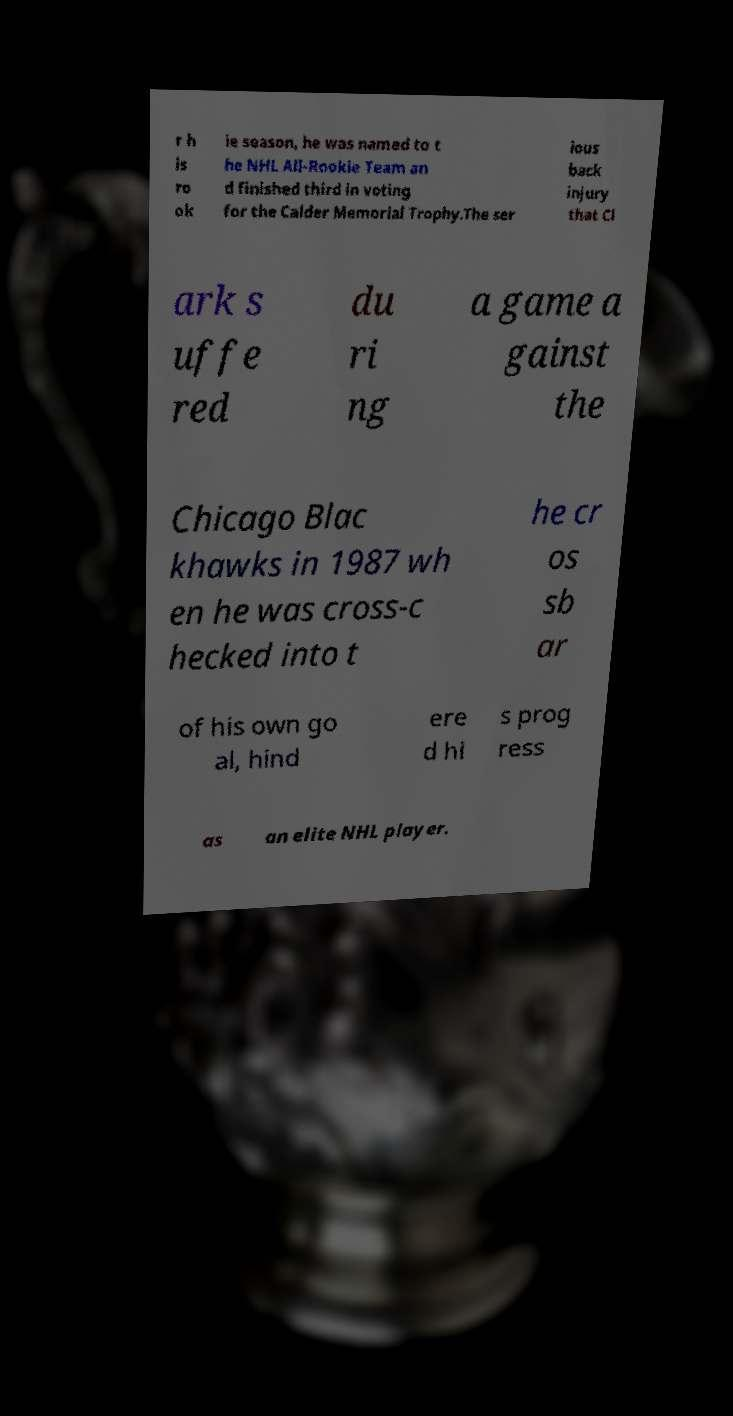Can you accurately transcribe the text from the provided image for me? r h is ro ok ie season, he was named to t he NHL All-Rookie Team an d finished third in voting for the Calder Memorial Trophy.The ser ious back injury that Cl ark s uffe red du ri ng a game a gainst the Chicago Blac khawks in 1987 wh en he was cross-c hecked into t he cr os sb ar of his own go al, hind ere d hi s prog ress as an elite NHL player. 